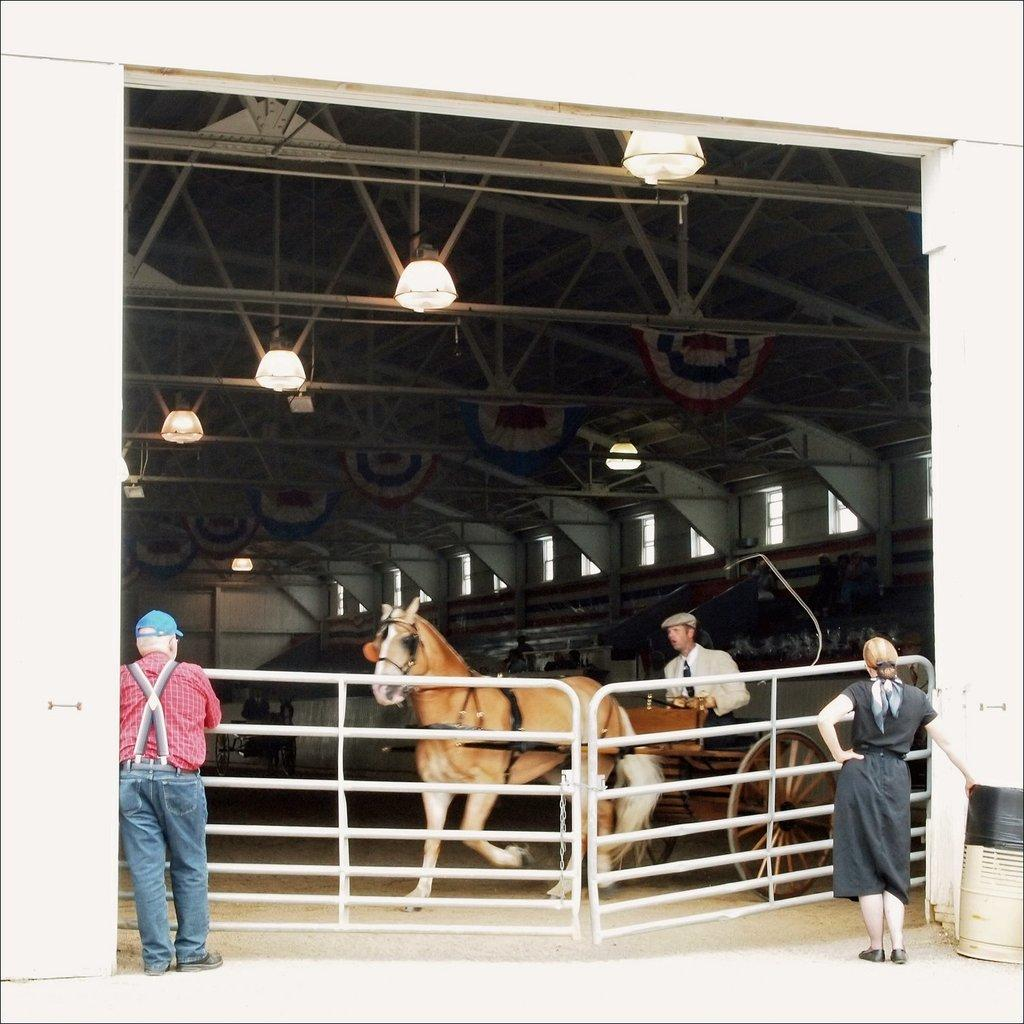How many people are on each side of the fencing in the image? There are two people standing on the left side of the fencing and two people standing on the right side of the fencing. What is located inside the fencing? There is a horse and a cart inside the fencing. Who is sitting on the cart? A person is sitting on the cart. What type of gold is being used to decorate the horse in the image? There is no gold present in the image, and the horse is not being decorated. 